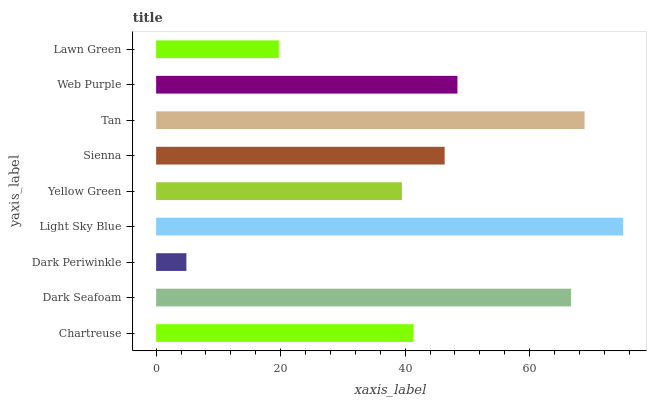Is Dark Periwinkle the minimum?
Answer yes or no. Yes. Is Light Sky Blue the maximum?
Answer yes or no. Yes. Is Dark Seafoam the minimum?
Answer yes or no. No. Is Dark Seafoam the maximum?
Answer yes or no. No. Is Dark Seafoam greater than Chartreuse?
Answer yes or no. Yes. Is Chartreuse less than Dark Seafoam?
Answer yes or no. Yes. Is Chartreuse greater than Dark Seafoam?
Answer yes or no. No. Is Dark Seafoam less than Chartreuse?
Answer yes or no. No. Is Sienna the high median?
Answer yes or no. Yes. Is Sienna the low median?
Answer yes or no. Yes. Is Chartreuse the high median?
Answer yes or no. No. Is Chartreuse the low median?
Answer yes or no. No. 